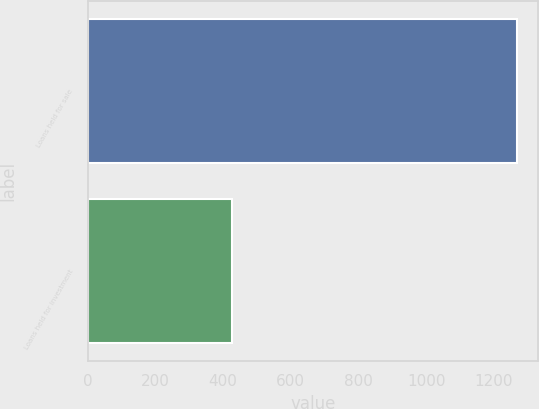<chart> <loc_0><loc_0><loc_500><loc_500><bar_chart><fcel>Loans held for sale<fcel>Loans held for investment<nl><fcel>1268<fcel>428<nl></chart> 